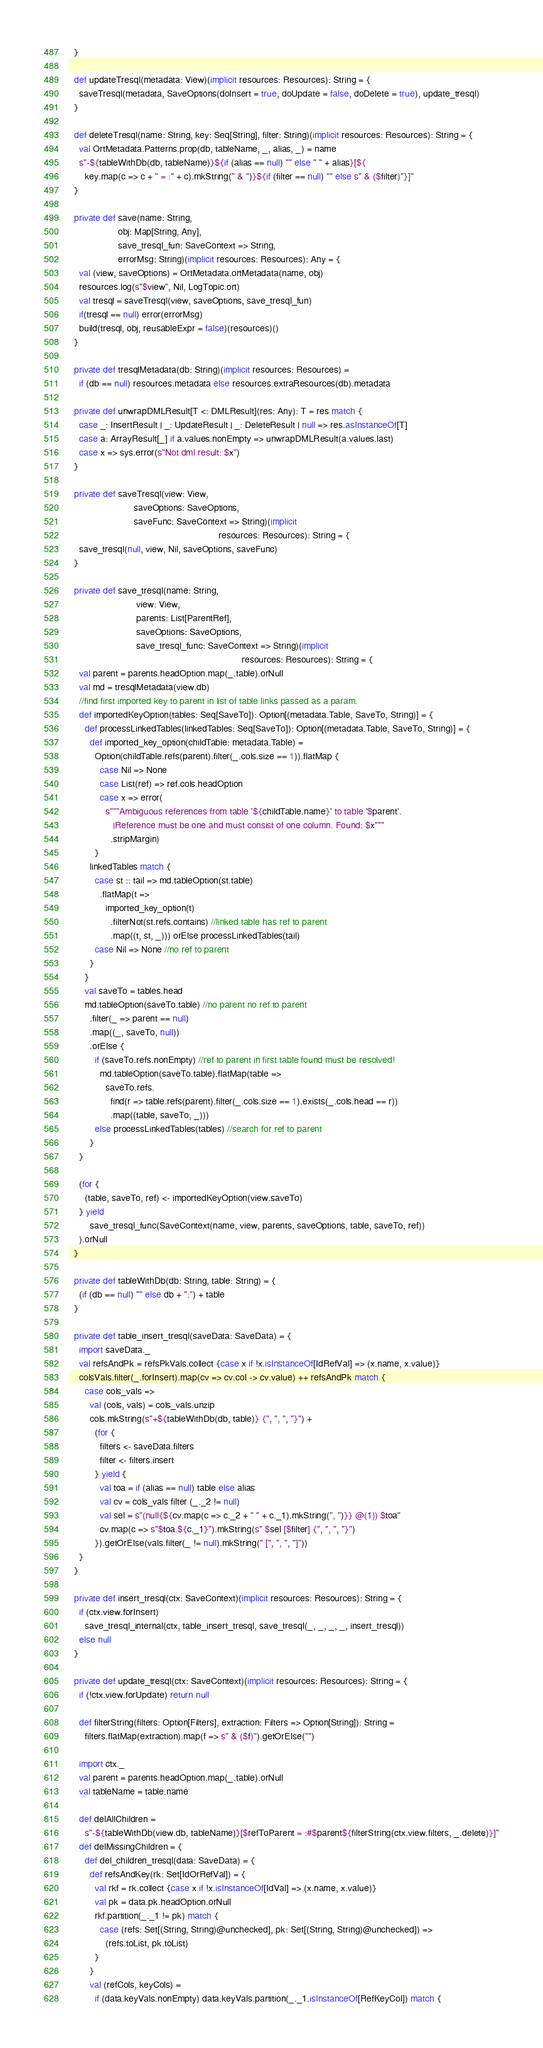<code> <loc_0><loc_0><loc_500><loc_500><_Scala_>  }

  def updateTresql(metadata: View)(implicit resources: Resources): String = {
    saveTresql(metadata, SaveOptions(doInsert = true, doUpdate = false, doDelete = true), update_tresql)
  }

  def deleteTresql(name: String, key: Seq[String], filter: String)(implicit resources: Resources): String = {
    val OrtMetadata.Patterns.prop(db, tableName, _, alias, _) = name
    s"-${tableWithDb(db, tableName)}${if (alias == null) "" else " " + alias}[${
      key.map(c => c + " = :" + c).mkString(" & ")}${if (filter == null) "" else s" & ($filter)"}]"
  }

  private def save(name: String,
                   obj: Map[String, Any],
                   save_tresql_fun: SaveContext => String,
                   errorMsg: String)(implicit resources: Resources): Any = {
    val (view, saveOptions) = OrtMetadata.ortMetadata(name, obj)
    resources.log(s"$view", Nil, LogTopic.ort)
    val tresql = saveTresql(view, saveOptions, save_tresql_fun)
    if(tresql == null) error(errorMsg)
    build(tresql, obj, reusableExpr = false)(resources)()
  }

  private def tresqlMetadata(db: String)(implicit resources: Resources) =
    if (db == null) resources.metadata else resources.extraResources(db).metadata

  private def unwrapDMLResult[T <: DMLResult](res: Any): T = res match {
    case _: InsertResult | _: UpdateResult | _: DeleteResult | null => res.asInstanceOf[T]
    case a: ArrayResult[_] if a.values.nonEmpty => unwrapDMLResult(a.values.last)
    case x => sys.error(s"Not dml result: $x")
  }

  private def saveTresql(view: View,
                         saveOptions: SaveOptions,
                         saveFunc: SaveContext => String)(implicit
                                                          resources: Resources): String = {
    save_tresql(null, view, Nil, saveOptions, saveFunc)
  }

  private def save_tresql(name: String,
                          view: View,
                          parents: List[ParentRef],
                          saveOptions: SaveOptions,
                          save_tresql_func: SaveContext => String)(implicit
                                                                   resources: Resources): String = {
    val parent = parents.headOption.map(_.table).orNull
    val md = tresqlMetadata(view.db)
    //find first imported key to parent in list of table links passed as a param.
    def importedKeyOption(tables: Seq[SaveTo]): Option[(metadata.Table, SaveTo, String)] = {
      def processLinkedTables(linkedTables: Seq[SaveTo]): Option[(metadata.Table, SaveTo, String)] = {
        def imported_key_option(childTable: metadata.Table) =
          Option(childTable.refs(parent).filter(_.cols.size == 1)).flatMap {
            case Nil => None
            case List(ref) => ref.cols.headOption
            case x => error(
              s"""Ambiguous references from table '${childTable.name}' to table '$parent'.
                 |Reference must be one and must consist of one column. Found: $x"""
                .stripMargin)
          }
        linkedTables match {
          case st :: tail => md.tableOption(st.table)
            .flatMap(t =>
              imported_key_option(t)
                .filterNot(st.refs.contains) //linked table has ref to parent
                .map((t, st, _))) orElse processLinkedTables(tail)
          case Nil => None //no ref to parent
        }
      }
      val saveTo = tables.head
      md.tableOption(saveTo.table) //no parent no ref to parent
        .filter(_ => parent == null)
        .map((_, saveTo, null))
        .orElse {
          if (saveTo.refs.nonEmpty) //ref to parent in first table found must be resolved!
            md.tableOption(saveTo.table).flatMap(table =>
              saveTo.refs.
                find(r => table.refs(parent).filter(_.cols.size == 1).exists(_.cols.head == r))
                .map((table, saveTo, _)))
          else processLinkedTables(tables) //search for ref to parent
        }
    }

    (for {
      (table, saveTo, ref) <- importedKeyOption(view.saveTo)
    } yield
        save_tresql_func(SaveContext(name, view, parents, saveOptions, table, saveTo, ref))
    ).orNull
  }

  private def tableWithDb(db: String, table: String) = {
    (if (db == null) "" else db + ":") + table
  }

  private def table_insert_tresql(saveData: SaveData) = {
    import saveData._
    val refsAndPk = refsPkVals.collect {case x if !x.isInstanceOf[IdRefVal] => (x.name, x.value)}
    colsVals.filter(_.forInsert).map(cv => cv.col -> cv.value) ++ refsAndPk match {
      case cols_vals =>
        val (cols, vals) = cols_vals.unzip
        cols.mkString(s"+${tableWithDb(db, table)} {", ", ", "}") +
          (for {
            filters <- saveData.filters
            filter <- filters.insert
          } yield {
            val toa = if (alias == null) table else alias
            val cv = cols_vals filter (_._2 != null)
            val sel = s"(null{${cv.map(c => c._2 + " " + c._1).mkString(", ")}} @(1)) $toa"
            cv.map(c => s"$toa.${c._1}").mkString(s" $sel [$filter] {", ", ", "}")
          }).getOrElse(vals.filter(_ != null).mkString(" [", ", ", "]"))
    }
  }

  private def insert_tresql(ctx: SaveContext)(implicit resources: Resources): String = {
    if (ctx.view.forInsert)
      save_tresql_internal(ctx, table_insert_tresql, save_tresql(_, _, _, _, insert_tresql))
    else null
  }

  private def update_tresql(ctx: SaveContext)(implicit resources: Resources): String = {
    if (!ctx.view.forUpdate) return null

    def filterString(filters: Option[Filters], extraction: Filters => Option[String]): String =
      filters.flatMap(extraction).map(f => s" & ($f)").getOrElse("")

    import ctx._
    val parent = parents.headOption.map(_.table).orNull
    val tableName = table.name

    def delAllChildren =
      s"-${tableWithDb(view.db, tableName)}[$refToParent = :#$parent${filterString(ctx.view.filters, _.delete)}]"
    def delMissingChildren = {
      def del_children_tresql(data: SaveData) = {
        def refsAndKey(rk: Set[IdOrRefVal]) = {
          val rkf = rk.collect {case x if !x.isInstanceOf[IdVal] => (x.name, x.value)}
          val pk = data.pk.headOption.orNull
          rkf.partition(_._1 != pk) match {
            case (refs: Set[(String, String)@unchecked], pk: Set[(String, String)@unchecked]) =>
              (refs.toList, pk.toList)
          }
        }
        val (refCols, keyCols) =
          if (data.keyVals.nonEmpty) data.keyVals.partition(_._1.isInstanceOf[RefKeyCol]) match {</code> 